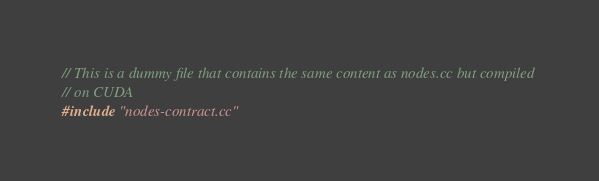<code> <loc_0><loc_0><loc_500><loc_500><_Cuda_>// This is a dummy file that contains the same content as nodes.cc but compiled
// on CUDA
#include "nodes-contract.cc"
</code> 